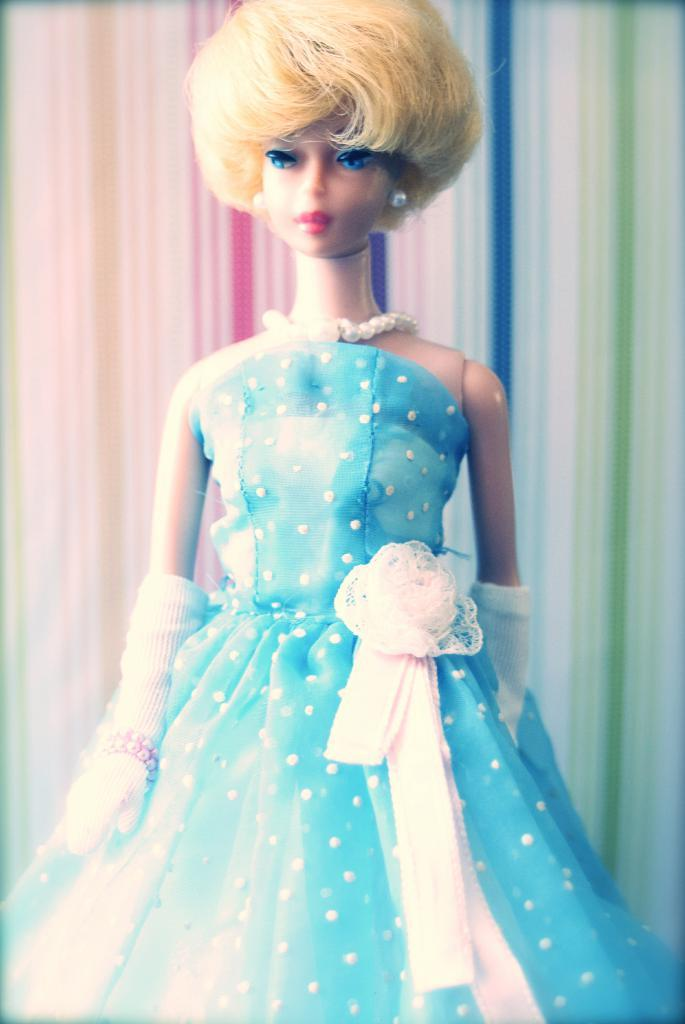What is the main subject of the image? There is a Barbie doll in the image. What is the Barbie doll wearing? The Barbie doll is wearing a blue dress. Can you describe the background of the image? The background of the image is colorful. What type of spark can be seen coming from the Barbie doll's head in the image? There is no spark coming from the Barbie doll's head in the image. What kind of beast is present in the image? There are no beasts present in the image; it features a Barbie doll and a colorful background. 